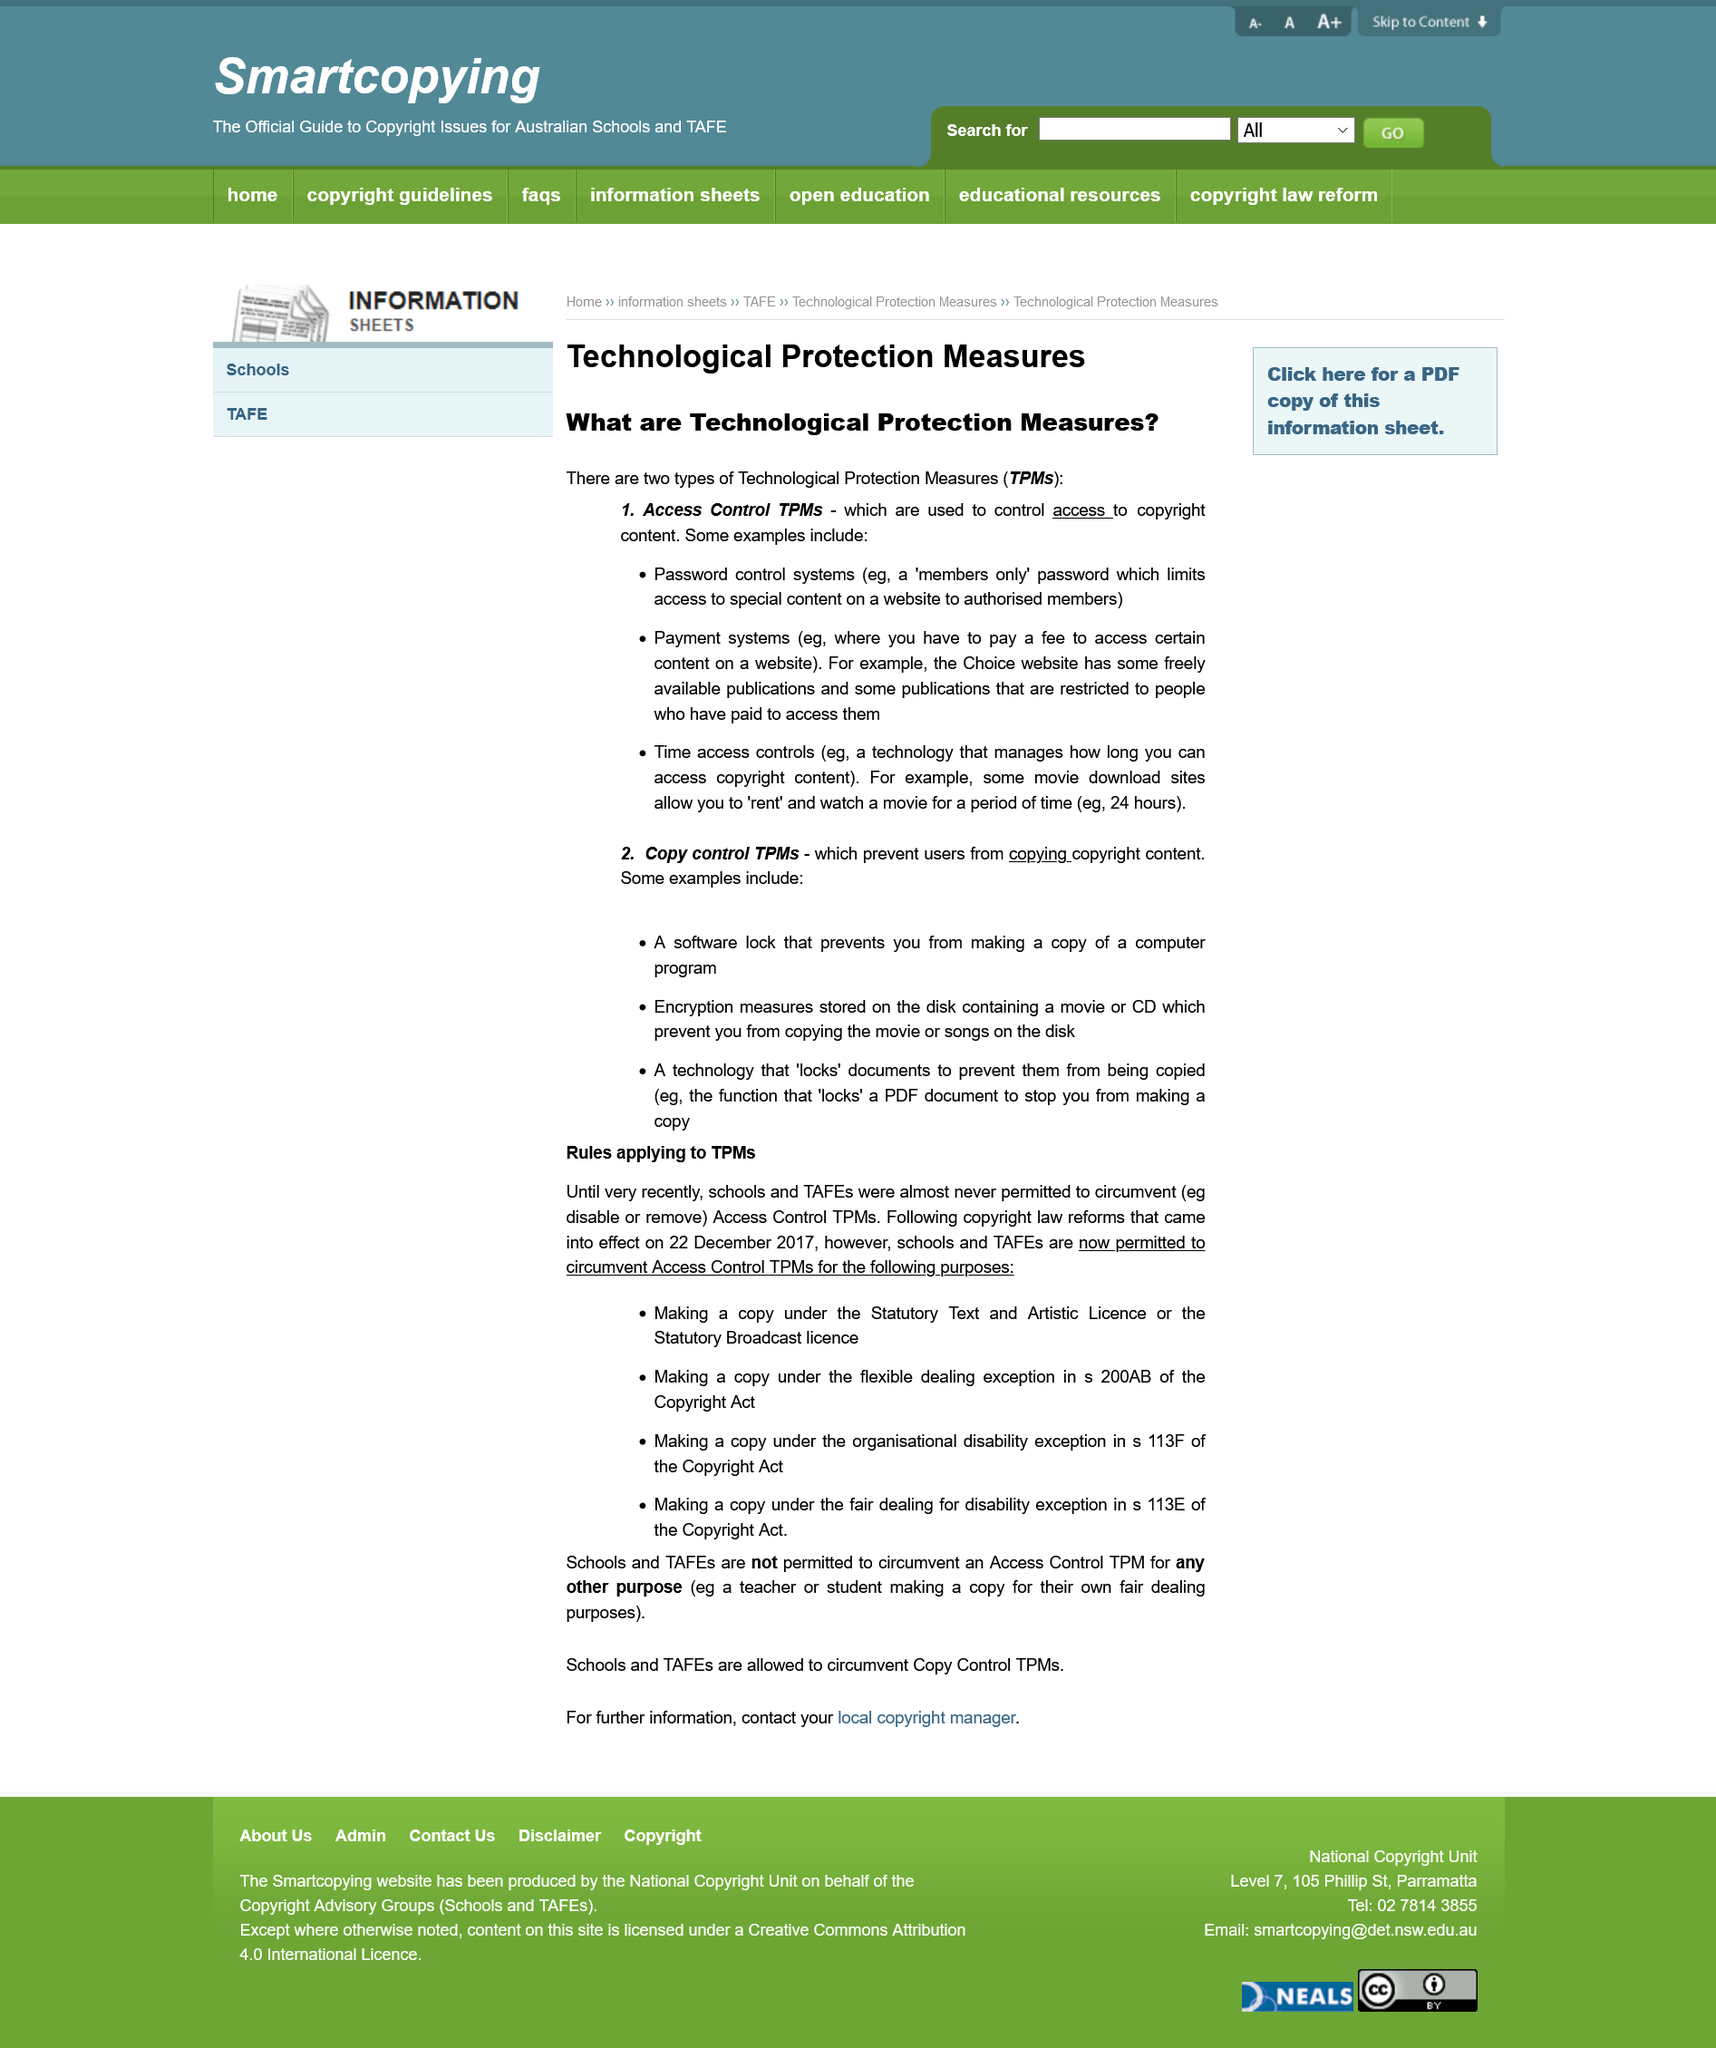Draw attention to some important aspects in this diagram. Password protection on a members-only area of a website is an access control technological protection measure (TPM). Two examples of technological protection measures for access control are password control systems and payment systems. The website has a paid members-only area that is protected by an access control technological protection measure. 